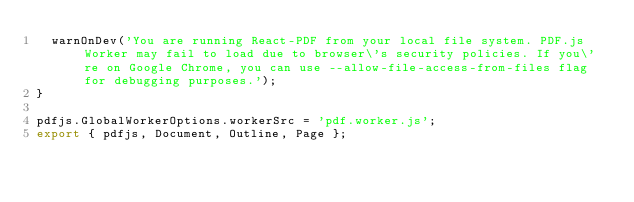<code> <loc_0><loc_0><loc_500><loc_500><_JavaScript_>  warnOnDev('You are running React-PDF from your local file system. PDF.js Worker may fail to load due to browser\'s security policies. If you\'re on Google Chrome, you can use --allow-file-access-from-files flag for debugging purposes.');
}

pdfjs.GlobalWorkerOptions.workerSrc = 'pdf.worker.js';
export { pdfjs, Document, Outline, Page };</code> 